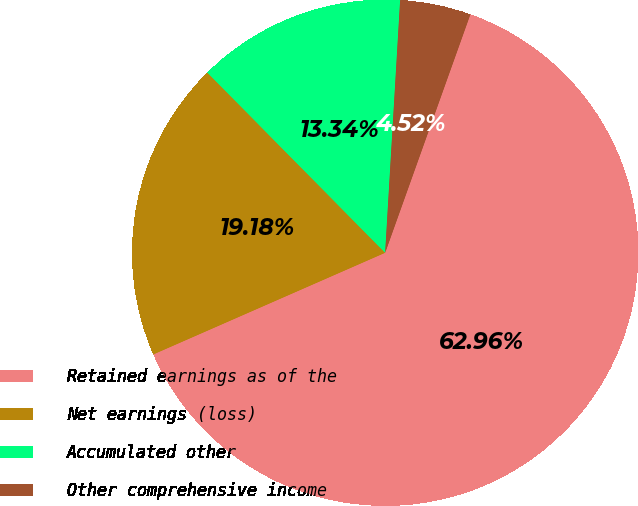Convert chart. <chart><loc_0><loc_0><loc_500><loc_500><pie_chart><fcel>Retained earnings as of the<fcel>Net earnings (loss)<fcel>Accumulated other<fcel>Other comprehensive income<nl><fcel>62.96%<fcel>19.18%<fcel>13.34%<fcel>4.52%<nl></chart> 